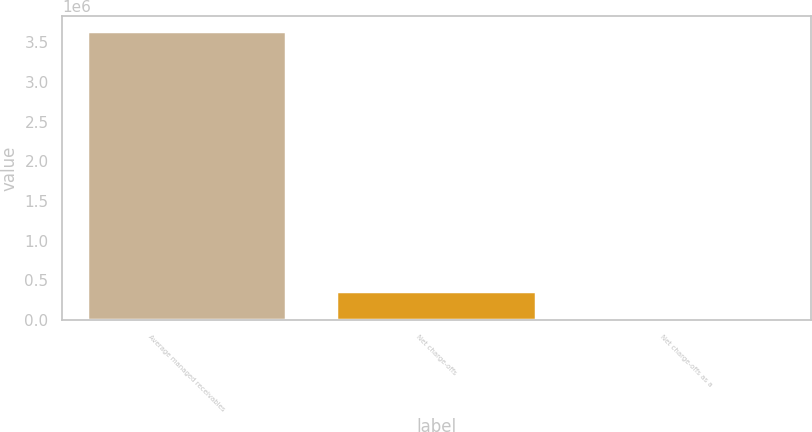<chart> <loc_0><loc_0><loc_500><loc_500><bar_chart><fcel>Average managed receivables<fcel>Net charge-offs<fcel>Net charge-offs as a<nl><fcel>3.64006e+06<fcel>364010<fcel>5<nl></chart> 